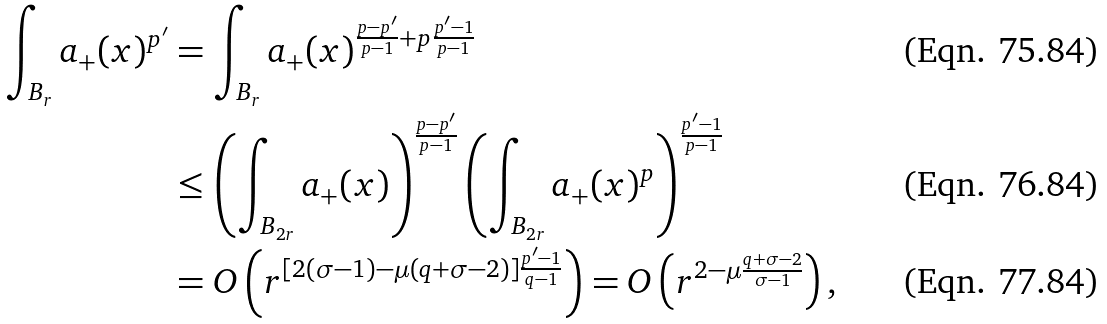<formula> <loc_0><loc_0><loc_500><loc_500>\int _ { B _ { r } } a _ { + } ( x ) ^ { p ^ { \prime } } & = \int _ { B _ { r } } a _ { + } ( x ) ^ { \frac { p - p ^ { \prime } } { p - 1 } + p \frac { p ^ { \prime } - 1 } { p - 1 } } \\ & \leq \left ( \int _ { B _ { 2 r } } a _ { + } ( x ) \right ) ^ { \frac { p - p ^ { \prime } } { p - 1 } } \left ( \int _ { B _ { 2 r } } a _ { + } ( x ) ^ { p } \right ) ^ { \frac { p ^ { \prime } - 1 } { p - 1 } } \\ & = O \left ( r ^ { [ 2 ( \sigma - 1 ) - \mu ( q + \sigma - 2 ) ] \frac { p ^ { \prime } - 1 } { q - 1 } } \right ) = O \left ( r ^ { 2 - \mu \frac { q + \sigma - 2 } { \sigma - 1 } } \right ) ,</formula> 